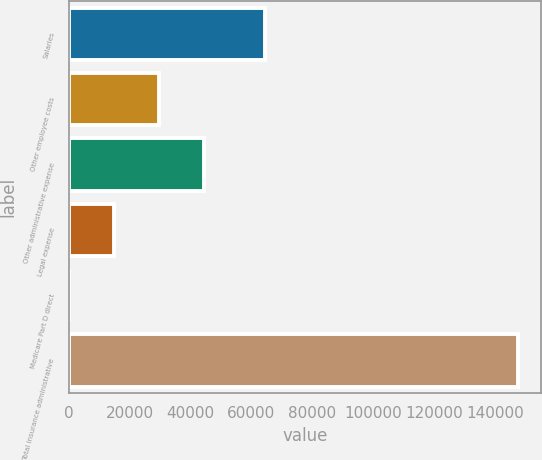Convert chart to OTSL. <chart><loc_0><loc_0><loc_500><loc_500><bar_chart><fcel>Salaries<fcel>Other employee costs<fcel>Other administrative expense<fcel>Legal expense<fcel>Medicare Part D direct<fcel>Total insurance administrative<nl><fcel>64339<fcel>29539<fcel>44306.7<fcel>14771.2<fcel>3.47<fcel>147681<nl></chart> 